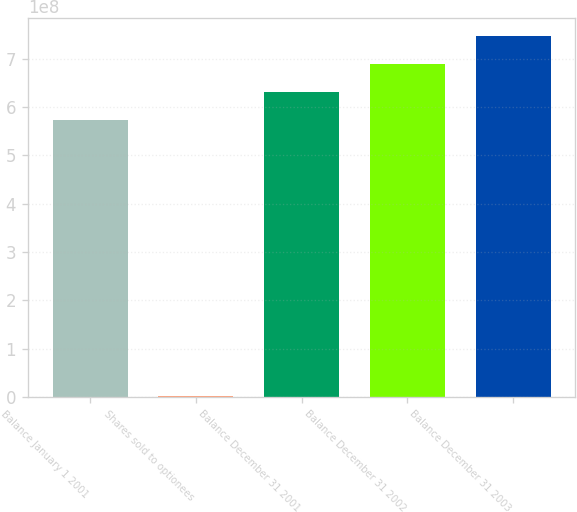Convert chart to OTSL. <chart><loc_0><loc_0><loc_500><loc_500><bar_chart><fcel>Balance January 1 2001<fcel>Shares sold to optionees<fcel>Balance December 31 2001<fcel>Balance December 31 2002<fcel>Balance December 31 2003<nl><fcel>5.72725e+08<fcel>1.40807e+06<fcel>6.31179e+08<fcel>6.89633e+08<fcel>7.48087e+08<nl></chart> 